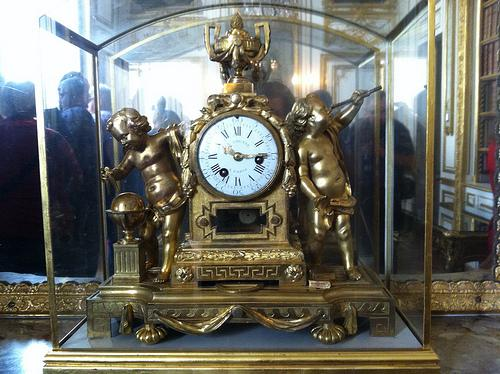Question: what color is the clock?
Choices:
A. Brown.
B. Black.
C. Gray.
D. Gold.
Answer with the letter. Answer: D Question: where is this scene?
Choices:
A. At an art's building.
B. At a museum.
C. At a historical building.
D. At a fine art's museum.
Answer with the letter. Answer: B Question: why is there a clock?
Choices:
A. For decoration.
B. To make noises.
C. Tell time.
D. An heirloom.
Answer with the letter. Answer: C Question: how is the photo?
Choices:
A. Dark.
B. Blurry.
C. Ripped.
D. Clear.
Answer with the letter. Answer: D Question: what else is visible?
Choices:
A. Bunch of flowers.
B. A sleeping cat.
C. Reflections.
D. A plate with a sandwich.
Answer with the letter. Answer: C Question: who is present?
Choices:
A. Cows.
B. Men.
C. People.
D. Women.
Answer with the letter. Answer: C 